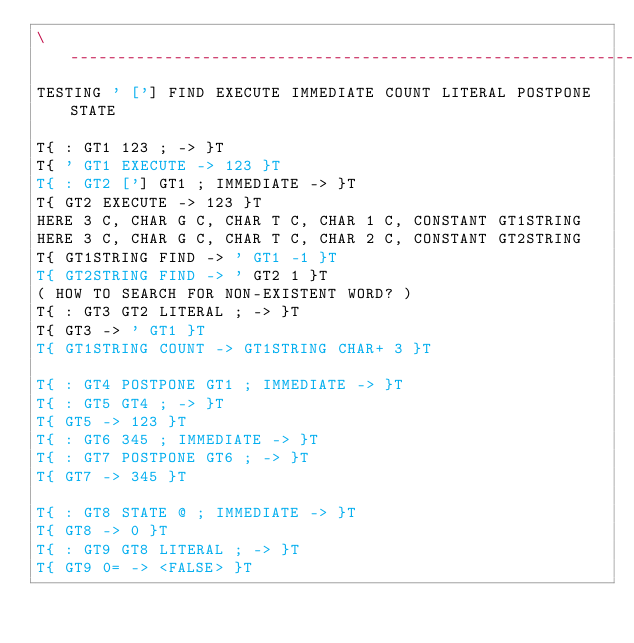<code> <loc_0><loc_0><loc_500><loc_500><_Forth_>\ ------------------------------------------------------------------------
TESTING ' ['] FIND EXECUTE IMMEDIATE COUNT LITERAL POSTPONE STATE

T{ : GT1 123 ; -> }T
T{ ' GT1 EXECUTE -> 123 }T
T{ : GT2 ['] GT1 ; IMMEDIATE -> }T
T{ GT2 EXECUTE -> 123 }T
HERE 3 C, CHAR G C, CHAR T C, CHAR 1 C, CONSTANT GT1STRING
HERE 3 C, CHAR G C, CHAR T C, CHAR 2 C, CONSTANT GT2STRING
T{ GT1STRING FIND -> ' GT1 -1 }T
T{ GT2STRING FIND -> ' GT2 1 }T
( HOW TO SEARCH FOR NON-EXISTENT WORD? )
T{ : GT3 GT2 LITERAL ; -> }T
T{ GT3 -> ' GT1 }T
T{ GT1STRING COUNT -> GT1STRING CHAR+ 3 }T

T{ : GT4 POSTPONE GT1 ; IMMEDIATE -> }T
T{ : GT5 GT4 ; -> }T
T{ GT5 -> 123 }T
T{ : GT6 345 ; IMMEDIATE -> }T
T{ : GT7 POSTPONE GT6 ; -> }T
T{ GT7 -> 345 }T

T{ : GT8 STATE @ ; IMMEDIATE -> }T
T{ GT8 -> 0 }T
T{ : GT9 GT8 LITERAL ; -> }T
T{ GT9 0= -> <FALSE> }T
</code> 